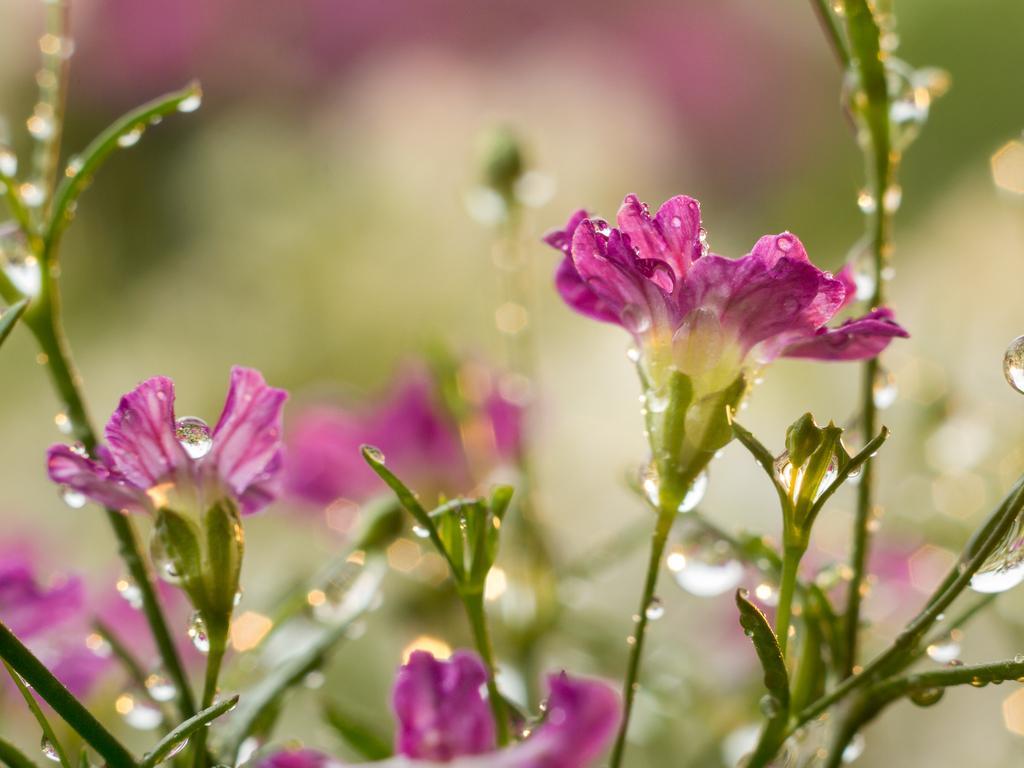In one or two sentences, can you explain what this image depicts? This is a zoomed in picture. In the foreground we can see the flowers, leaves and the plants and we can see the water droplets on the flowers. The background of the image is very blurry. 